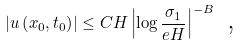<formula> <loc_0><loc_0><loc_500><loc_500>\left | u \left ( x _ { 0 } , t _ { 0 } \right ) \right | \leq C H \left | \log \frac { \sigma _ { 1 } } { e H } \right | ^ { - B } \text { ,}</formula> 